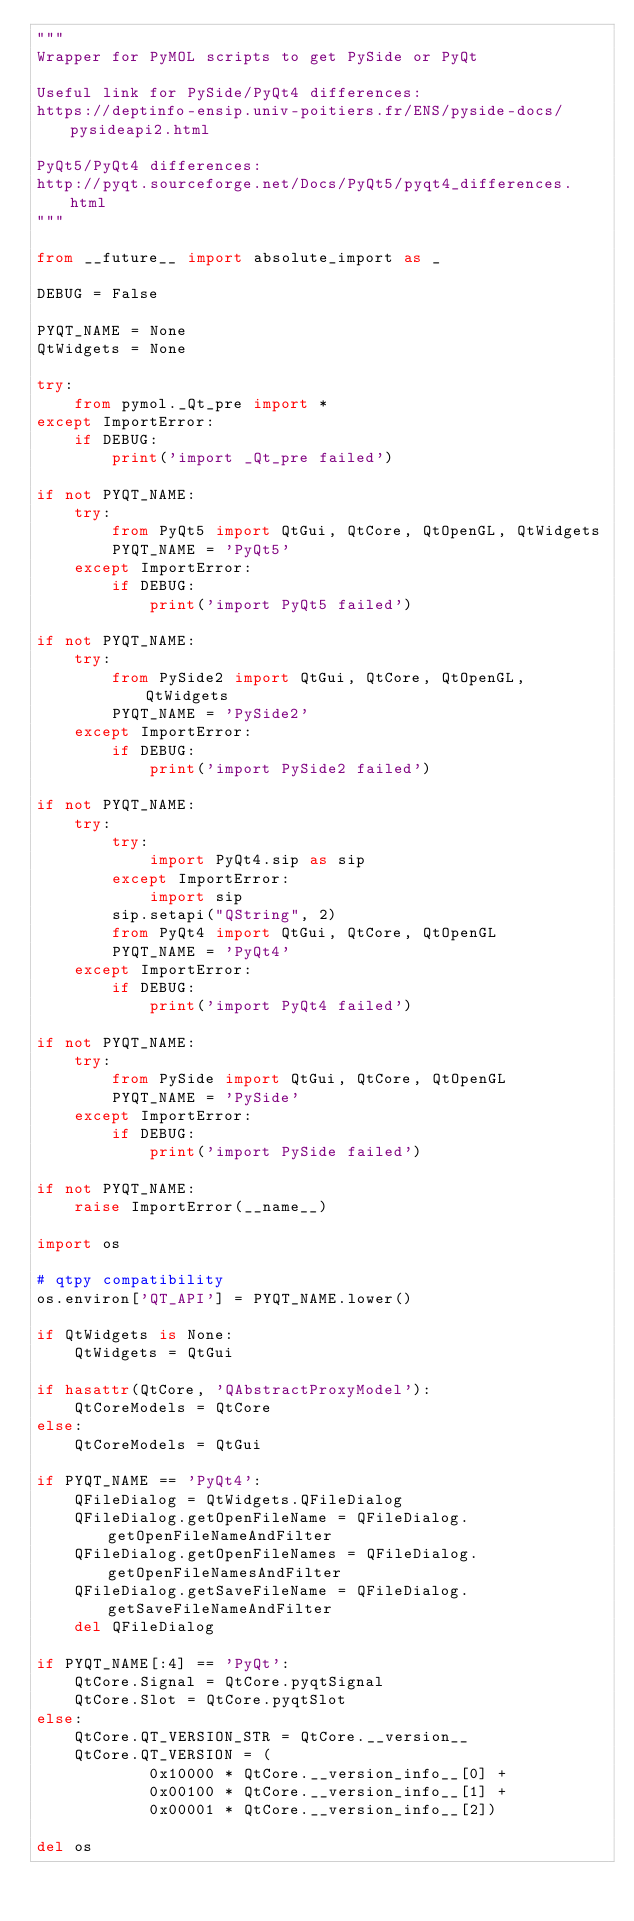Convert code to text. <code><loc_0><loc_0><loc_500><loc_500><_Python_>"""
Wrapper for PyMOL scripts to get PySide or PyQt

Useful link for PySide/PyQt4 differences:
https://deptinfo-ensip.univ-poitiers.fr/ENS/pyside-docs/pysideapi2.html

PyQt5/PyQt4 differences:
http://pyqt.sourceforge.net/Docs/PyQt5/pyqt4_differences.html
"""

from __future__ import absolute_import as _

DEBUG = False

PYQT_NAME = None
QtWidgets = None

try:
    from pymol._Qt_pre import *
except ImportError:
    if DEBUG:
        print('import _Qt_pre failed')

if not PYQT_NAME:
    try:
        from PyQt5 import QtGui, QtCore, QtOpenGL, QtWidgets
        PYQT_NAME = 'PyQt5'
    except ImportError:
        if DEBUG:
            print('import PyQt5 failed')

if not PYQT_NAME:
    try:
        from PySide2 import QtGui, QtCore, QtOpenGL, QtWidgets
        PYQT_NAME = 'PySide2'
    except ImportError:
        if DEBUG:
            print('import PySide2 failed')

if not PYQT_NAME:
    try:
        try:
            import PyQt4.sip as sip
        except ImportError:
            import sip
        sip.setapi("QString", 2)
        from PyQt4 import QtGui, QtCore, QtOpenGL
        PYQT_NAME = 'PyQt4'
    except ImportError:
        if DEBUG:
            print('import PyQt4 failed')

if not PYQT_NAME:
    try:
        from PySide import QtGui, QtCore, QtOpenGL
        PYQT_NAME = 'PySide'
    except ImportError:
        if DEBUG:
            print('import PySide failed')

if not PYQT_NAME:
    raise ImportError(__name__)

import os

# qtpy compatibility
os.environ['QT_API'] = PYQT_NAME.lower()

if QtWidgets is None:
    QtWidgets = QtGui

if hasattr(QtCore, 'QAbstractProxyModel'):
    QtCoreModels = QtCore
else:
    QtCoreModels = QtGui

if PYQT_NAME == 'PyQt4':
    QFileDialog = QtWidgets.QFileDialog
    QFileDialog.getOpenFileName = QFileDialog.getOpenFileNameAndFilter
    QFileDialog.getOpenFileNames = QFileDialog.getOpenFileNamesAndFilter
    QFileDialog.getSaveFileName = QFileDialog.getSaveFileNameAndFilter
    del QFileDialog

if PYQT_NAME[:4] == 'PyQt':
    QtCore.Signal = QtCore.pyqtSignal
    QtCore.Slot = QtCore.pyqtSlot
else:
    QtCore.QT_VERSION_STR = QtCore.__version__
    QtCore.QT_VERSION = (
            0x10000 * QtCore.__version_info__[0] +
            0x00100 * QtCore.__version_info__[1] +
            0x00001 * QtCore.__version_info__[2])

del os
</code> 